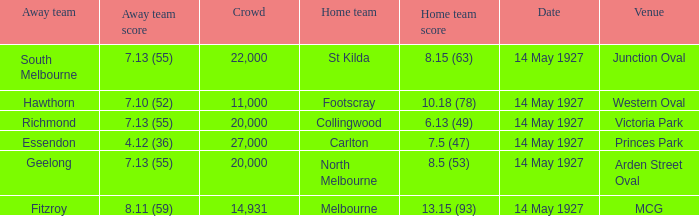What was the home team when the Geelong away team had a score of 7.13 (55)? North Melbourne. 